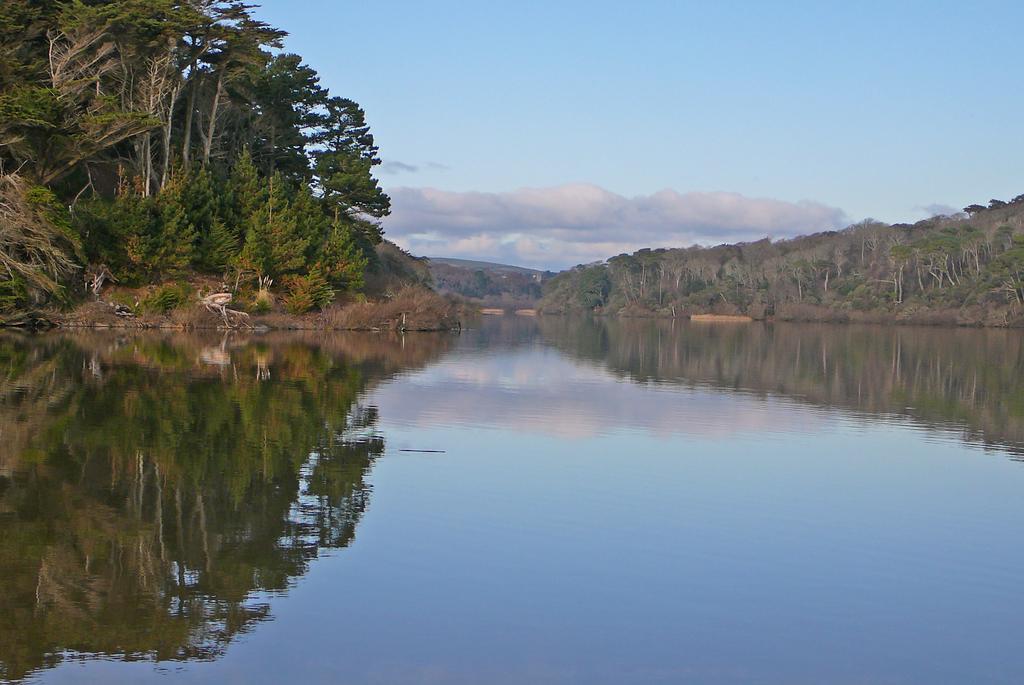In one or two sentences, can you explain what this image depicts? In the image we can see water, trees, hill and the cloudy sky. 